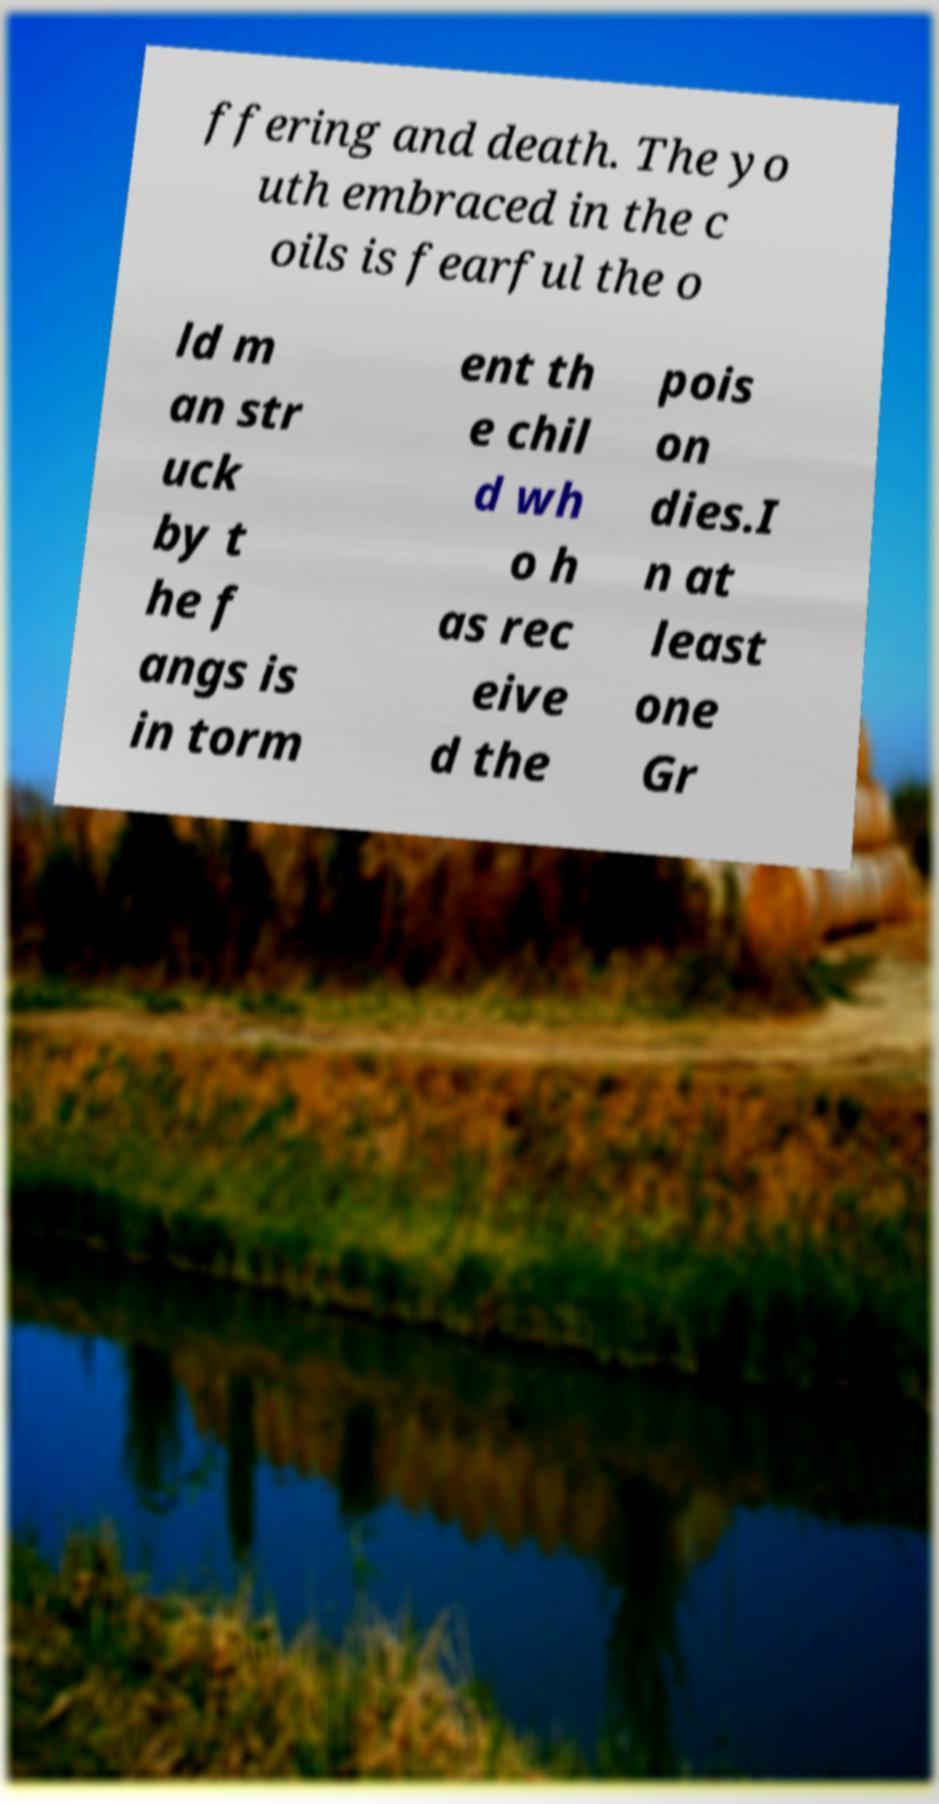Please read and relay the text visible in this image. What does it say? ffering and death. The yo uth embraced in the c oils is fearful the o ld m an str uck by t he f angs is in torm ent th e chil d wh o h as rec eive d the pois on dies.I n at least one Gr 